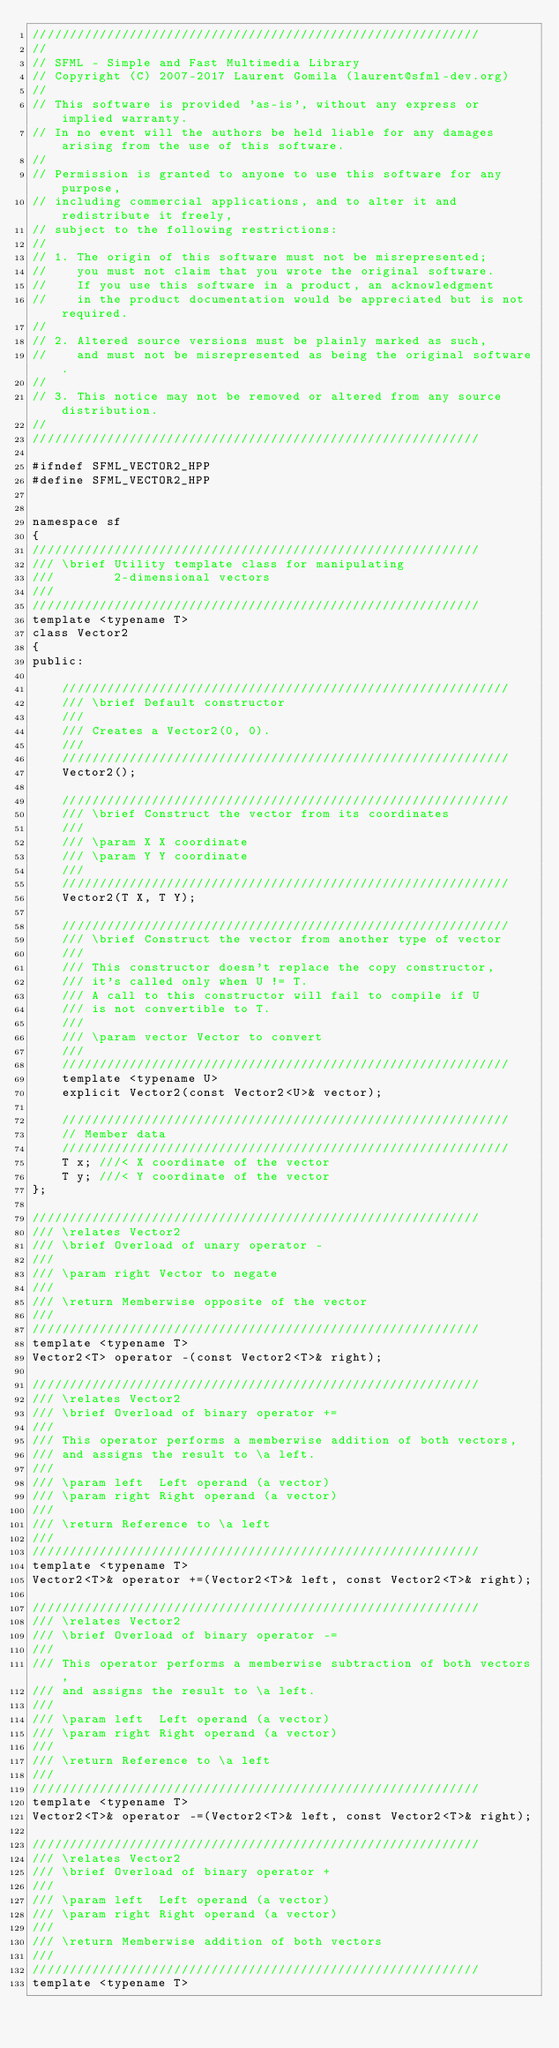Convert code to text. <code><loc_0><loc_0><loc_500><loc_500><_C++_>////////////////////////////////////////////////////////////
//
// SFML - Simple and Fast Multimedia Library
// Copyright (C) 2007-2017 Laurent Gomila (laurent@sfml-dev.org)
//
// This software is provided 'as-is', without any express or implied warranty.
// In no event will the authors be held liable for any damages arising from the use of this software.
//
// Permission is granted to anyone to use this software for any purpose,
// including commercial applications, and to alter it and redistribute it freely,
// subject to the following restrictions:
//
// 1. The origin of this software must not be misrepresented;
//    you must not claim that you wrote the original software.
//    If you use this software in a product, an acknowledgment
//    in the product documentation would be appreciated but is not required.
//
// 2. Altered source versions must be plainly marked as such,
//    and must not be misrepresented as being the original software.
//
// 3. This notice may not be removed or altered from any source distribution.
//
////////////////////////////////////////////////////////////

#ifndef SFML_VECTOR2_HPP
#define SFML_VECTOR2_HPP


namespace sf
{
////////////////////////////////////////////////////////////
/// \brief Utility template class for manipulating
///        2-dimensional vectors
///
////////////////////////////////////////////////////////////
template <typename T>
class Vector2
{
public:

    ////////////////////////////////////////////////////////////
    /// \brief Default constructor
    ///
    /// Creates a Vector2(0, 0).
    ///
    ////////////////////////////////////////////////////////////
    Vector2();

    ////////////////////////////////////////////////////////////
    /// \brief Construct the vector from its coordinates
    ///
    /// \param X X coordinate
    /// \param Y Y coordinate
    ///
    ////////////////////////////////////////////////////////////
    Vector2(T X, T Y);

    ////////////////////////////////////////////////////////////
    /// \brief Construct the vector from another type of vector
    ///
    /// This constructor doesn't replace the copy constructor,
    /// it's called only when U != T.
    /// A call to this constructor will fail to compile if U
    /// is not convertible to T.
    ///
    /// \param vector Vector to convert
    ///
    ////////////////////////////////////////////////////////////
    template <typename U>
    explicit Vector2(const Vector2<U>& vector);

    ////////////////////////////////////////////////////////////
    // Member data
    ////////////////////////////////////////////////////////////
    T x; ///< X coordinate of the vector
    T y; ///< Y coordinate of the vector
};

////////////////////////////////////////////////////////////
/// \relates Vector2
/// \brief Overload of unary operator -
///
/// \param right Vector to negate
///
/// \return Memberwise opposite of the vector
///
////////////////////////////////////////////////////////////
template <typename T>
Vector2<T> operator -(const Vector2<T>& right);

////////////////////////////////////////////////////////////
/// \relates Vector2
/// \brief Overload of binary operator +=
///
/// This operator performs a memberwise addition of both vectors,
/// and assigns the result to \a left.
///
/// \param left  Left operand (a vector)
/// \param right Right operand (a vector)
///
/// \return Reference to \a left
///
////////////////////////////////////////////////////////////
template <typename T>
Vector2<T>& operator +=(Vector2<T>& left, const Vector2<T>& right);

////////////////////////////////////////////////////////////
/// \relates Vector2
/// \brief Overload of binary operator -=
///
/// This operator performs a memberwise subtraction of both vectors,
/// and assigns the result to \a left.
///
/// \param left  Left operand (a vector)
/// \param right Right operand (a vector)
///
/// \return Reference to \a left
///
////////////////////////////////////////////////////////////
template <typename T>
Vector2<T>& operator -=(Vector2<T>& left, const Vector2<T>& right);

////////////////////////////////////////////////////////////
/// \relates Vector2
/// \brief Overload of binary operator +
///
/// \param left  Left operand (a vector)
/// \param right Right operand (a vector)
///
/// \return Memberwise addition of both vectors
///
////////////////////////////////////////////////////////////
template <typename T></code> 